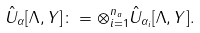<formula> <loc_0><loc_0><loc_500><loc_500>\hat { U } _ { \alpha } [ \Lambda , Y ] \colon = \otimes _ { i = 1 } ^ { n _ { a } } \hat { U } _ { \alpha _ { i } } [ \Lambda , Y ] .</formula> 